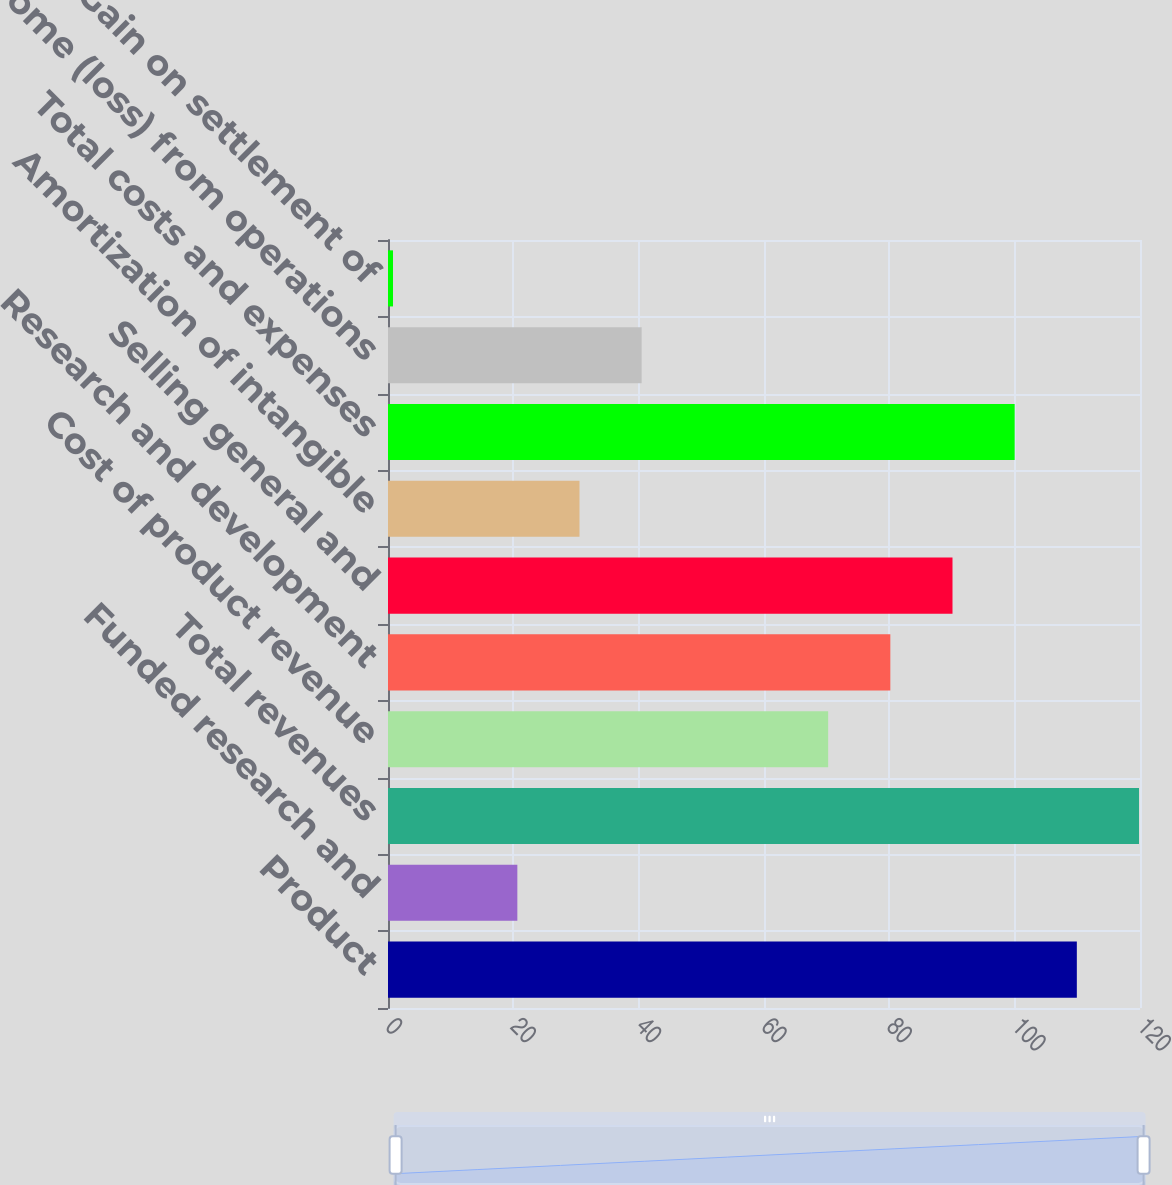<chart> <loc_0><loc_0><loc_500><loc_500><bar_chart><fcel>Product<fcel>Funded research and<fcel>Total revenues<fcel>Cost of product revenue<fcel>Research and development<fcel>Selling general and<fcel>Amortization of intangible<fcel>Total costs and expenses<fcel>Income (loss) from operations<fcel>Gain on settlement of<nl><fcel>109.92<fcel>20.64<fcel>119.84<fcel>70.24<fcel>80.16<fcel>90.08<fcel>30.56<fcel>100<fcel>40.48<fcel>0.8<nl></chart> 